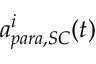Convert formula to latex. <formula><loc_0><loc_0><loc_500><loc_500>a _ { p a r a , S C } ^ { i } ( t )</formula> 